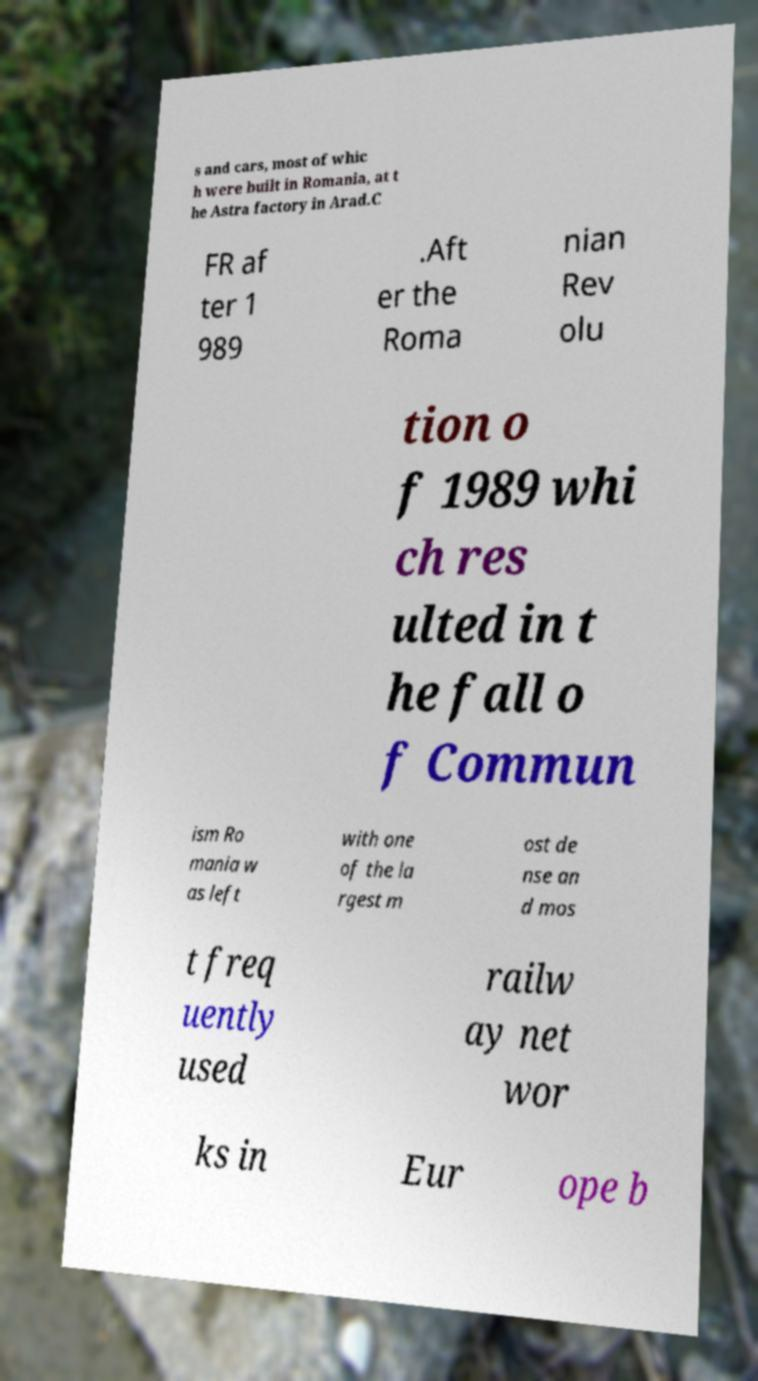Could you extract and type out the text from this image? s and cars, most of whic h were built in Romania, at t he Astra factory in Arad.C FR af ter 1 989 .Aft er the Roma nian Rev olu tion o f 1989 whi ch res ulted in t he fall o f Commun ism Ro mania w as left with one of the la rgest m ost de nse an d mos t freq uently used railw ay net wor ks in Eur ope b 